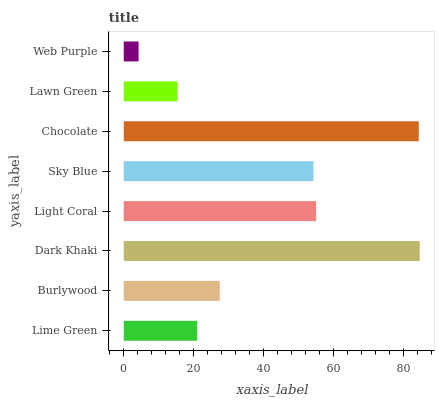Is Web Purple the minimum?
Answer yes or no. Yes. Is Dark Khaki the maximum?
Answer yes or no. Yes. Is Burlywood the minimum?
Answer yes or no. No. Is Burlywood the maximum?
Answer yes or no. No. Is Burlywood greater than Lime Green?
Answer yes or no. Yes. Is Lime Green less than Burlywood?
Answer yes or no. Yes. Is Lime Green greater than Burlywood?
Answer yes or no. No. Is Burlywood less than Lime Green?
Answer yes or no. No. Is Sky Blue the high median?
Answer yes or no. Yes. Is Burlywood the low median?
Answer yes or no. Yes. Is Lime Green the high median?
Answer yes or no. No. Is Chocolate the low median?
Answer yes or no. No. 